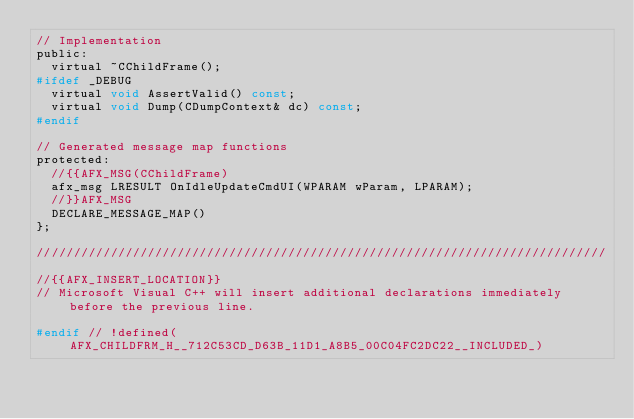Convert code to text. <code><loc_0><loc_0><loc_500><loc_500><_C_>// Implementation
public:
	virtual ~CChildFrame();
#ifdef _DEBUG
	virtual void AssertValid() const;
	virtual void Dump(CDumpContext& dc) const;
#endif

// Generated message map functions
protected:
	//{{AFX_MSG(CChildFrame)
	afx_msg LRESULT OnIdleUpdateCmdUI(WPARAM wParam, LPARAM);
	//}}AFX_MSG
	DECLARE_MESSAGE_MAP()
};

/////////////////////////////////////////////////////////////////////////////

//{{AFX_INSERT_LOCATION}}
// Microsoft Visual C++ will insert additional declarations immediately before the previous line.

#endif // !defined(AFX_CHILDFRM_H__712C53CD_D63B_11D1_A8B5_00C04FC2DC22__INCLUDED_)
</code> 